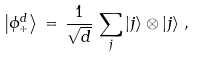Convert formula to latex. <formula><loc_0><loc_0><loc_500><loc_500>\left | \phi ^ { d } _ { + } \right \rangle \, = \, \frac { 1 } { \sqrt { d } } \, \sum _ { j } \left | j \right \rangle \otimes \left | j \right \rangle \, ,</formula> 